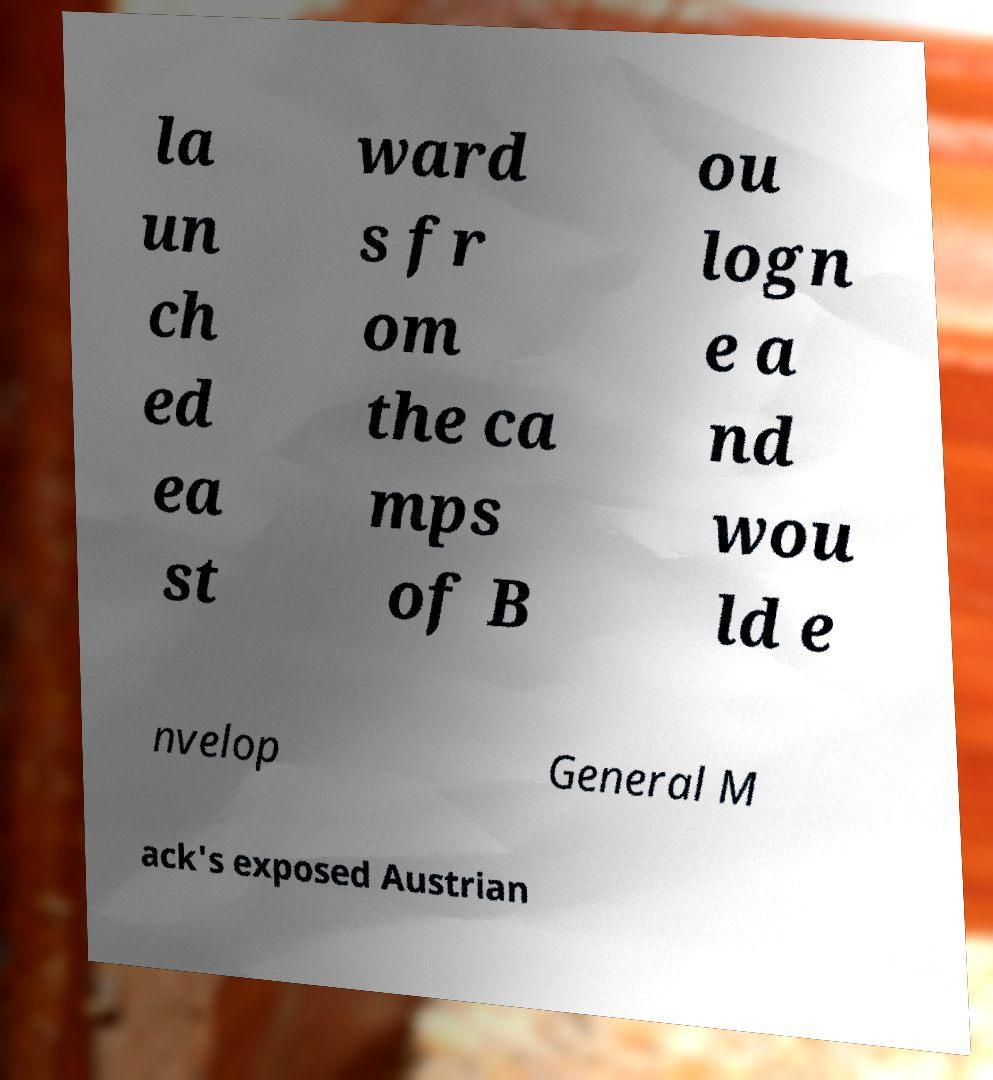Can you read and provide the text displayed in the image?This photo seems to have some interesting text. Can you extract and type it out for me? la un ch ed ea st ward s fr om the ca mps of B ou logn e a nd wou ld e nvelop General M ack's exposed Austrian 